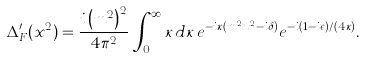Convert formula to latex. <formula><loc_0><loc_0><loc_500><loc_500>\Delta _ { F } ^ { \prime } ( x ^ { 2 } ) = { \frac { i \left ( m ^ { 2 } \right ) ^ { 2 } } { 4 \pi ^ { 2 } } } \, \int _ { 0 } ^ { \infty } \kappa \, d \kappa \, e ^ { - i \kappa ( m ^ { 2 } x ^ { 2 } - i \delta ) } e ^ { - i ( 1 - i \epsilon ) / ( 4 \kappa ) } .</formula> 